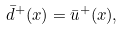Convert formula to latex. <formula><loc_0><loc_0><loc_500><loc_500>\bar { d } ^ { + } ( x ) = \bar { u } ^ { + } ( x ) ,</formula> 